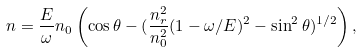<formula> <loc_0><loc_0><loc_500><loc_500>n = \frac { E } { \omega } n _ { 0 } \left ( \cos \theta - ( \frac { n _ { r } ^ { 2 } } { n _ { 0 } ^ { 2 } } ( 1 - \omega / E ) ^ { 2 } - \sin ^ { 2 } \theta ) ^ { 1 / 2 } \right ) ,</formula> 